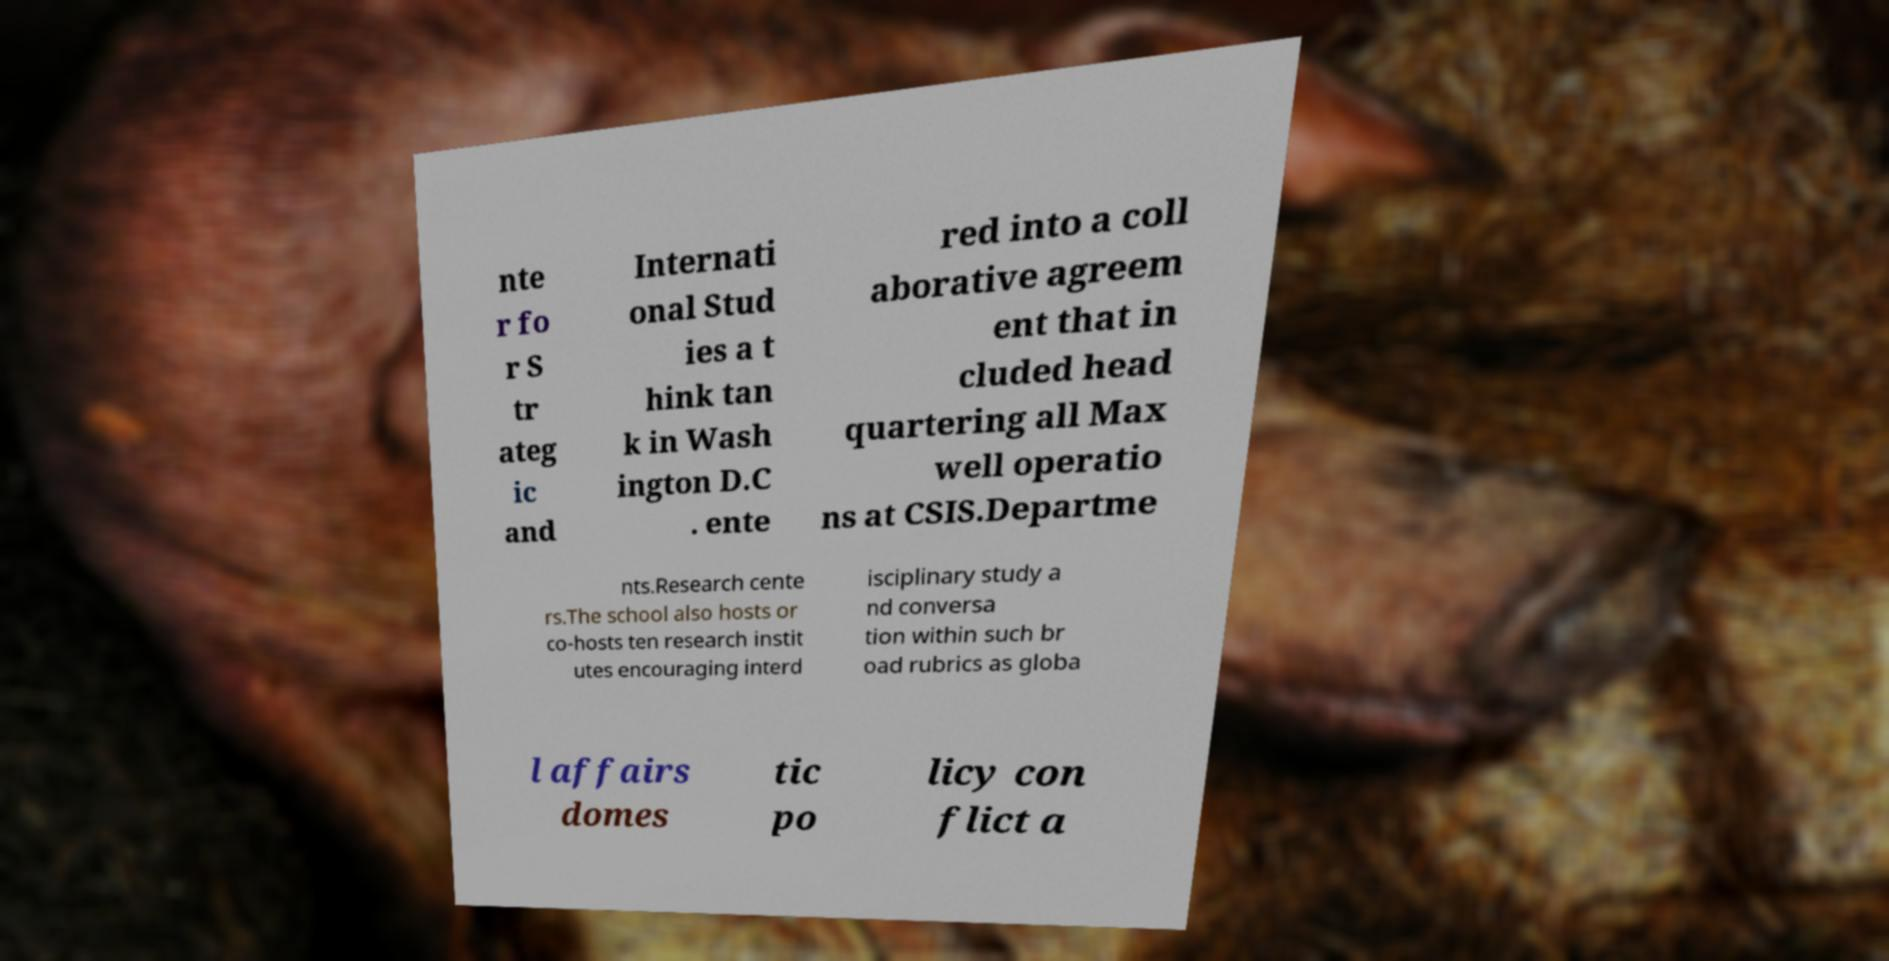What messages or text are displayed in this image? I need them in a readable, typed format. nte r fo r S tr ateg ic and Internati onal Stud ies a t hink tan k in Wash ington D.C . ente red into a coll aborative agreem ent that in cluded head quartering all Max well operatio ns at CSIS.Departme nts.Research cente rs.The school also hosts or co-hosts ten research instit utes encouraging interd isciplinary study a nd conversa tion within such br oad rubrics as globa l affairs domes tic po licy con flict a 